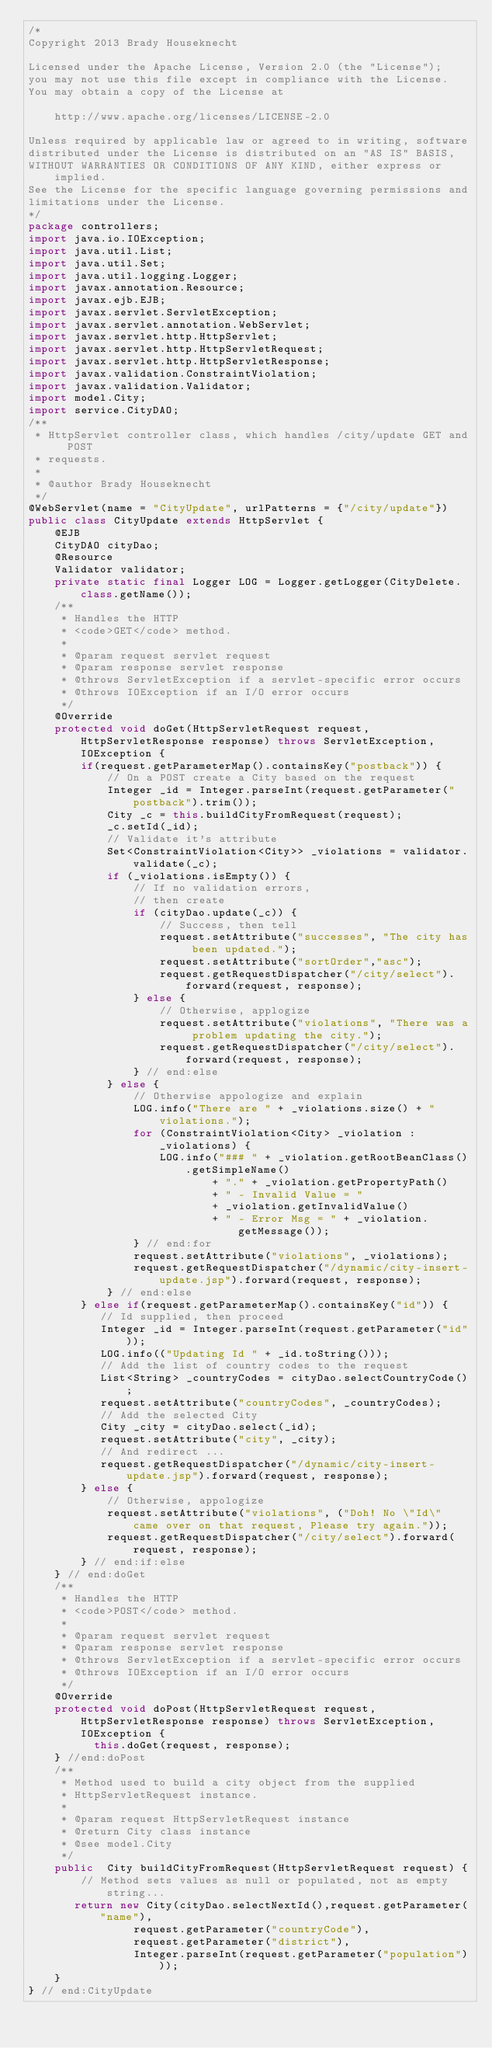Convert code to text. <code><loc_0><loc_0><loc_500><loc_500><_Java_>/*
Copyright 2013 Brady Houseknecht

Licensed under the Apache License, Version 2.0 (the "License");
you may not use this file except in compliance with the License.
You may obtain a copy of the License at

    http://www.apache.org/licenses/LICENSE-2.0

Unless required by applicable law or agreed to in writing, software
distributed under the License is distributed on an "AS IS" BASIS,
WITHOUT WARRANTIES OR CONDITIONS OF ANY KIND, either express or implied.
See the License for the specific language governing permissions and
limitations under the License.
*/
package controllers;
import java.io.IOException;
import java.util.List;
import java.util.Set;
import java.util.logging.Logger;
import javax.annotation.Resource;
import javax.ejb.EJB;
import javax.servlet.ServletException;
import javax.servlet.annotation.WebServlet;
import javax.servlet.http.HttpServlet;
import javax.servlet.http.HttpServletRequest;
import javax.servlet.http.HttpServletResponse;
import javax.validation.ConstraintViolation;
import javax.validation.Validator;
import model.City;
import service.CityDAO;
/**
 * HttpServlet controller class, which handles /city/update GET and POST
 * requests.
 * 
 * @author Brady Houseknecht
 */
@WebServlet(name = "CityUpdate", urlPatterns = {"/city/update"})
public class CityUpdate extends HttpServlet {
    @EJB
    CityDAO cityDao;
    @Resource
    Validator validator;
    private static final Logger LOG = Logger.getLogger(CityDelete.class.getName());
    /**
     * Handles the HTTP
     * <code>GET</code> method.
     *
     * @param request servlet request
     * @param response servlet response
     * @throws ServletException if a servlet-specific error occurs
     * @throws IOException if an I/O error occurs
     */
    @Override
    protected void doGet(HttpServletRequest request, HttpServletResponse response) throws ServletException, IOException {
        if(request.getParameterMap().containsKey("postback")) {
            // On a POST create a City based on the request
            Integer _id = Integer.parseInt(request.getParameter("postback").trim());
            City _c = this.buildCityFromRequest(request);
            _c.setId(_id);
            // Validate it's attribute
            Set<ConstraintViolation<City>> _violations = validator.validate(_c);
            if (_violations.isEmpty()) {
                // If no validation errors, 
                // then create
                if (cityDao.update(_c)) {
                    // Success, then tell
                    request.setAttribute("successes", "The city has been updated.");
                    request.setAttribute("sortOrder","asc");
                    request.getRequestDispatcher("/city/select").forward(request, response);
                } else {
                    // Otherwise, applogize
                    request.setAttribute("violations", "There was a problem updating the city.");
                    request.getRequestDispatcher("/city/select").forward(request, response);
                } // end:else
            } else {
                // Otherwise appologize and explain
                LOG.info("There are " + _violations.size() + " violations.");
                for (ConstraintViolation<City> _violation : _violations) {
                    LOG.info("### " + _violation.getRootBeanClass().getSimpleName()
                            + "." + _violation.getPropertyPath()
                            + " - Invalid Value = "
                            + _violation.getInvalidValue()
                            + " - Error Msg = " + _violation.getMessage());
                } // end:for            
                request.setAttribute("violations", _violations);
                request.getRequestDispatcher("/dynamic/city-insert-update.jsp").forward(request, response);
            } // end:else 
        } else if(request.getParameterMap().containsKey("id")) {
           // Id supplied, then proceed
           Integer _id = Integer.parseInt(request.getParameter("id"));
           LOG.info(("Updating Id " + _id.toString()));
           // Add the list of country codes to the request
           List<String> _countryCodes = cityDao.selectCountryCode();
           request.setAttribute("countryCodes", _countryCodes);
           // Add the selected City 
           City _city = cityDao.select(_id);
           request.setAttribute("city", _city);
           // And redirect ...
           request.getRequestDispatcher("/dynamic/city-insert-update.jsp").forward(request, response);
        } else {
            // Otherwise, appologize
            request.setAttribute("violations", ("Doh! No \"Id\" came over on that request, Please try again."));
            request.getRequestDispatcher("/city/select").forward(request, response);
        } // end:if:else
    } // end:doGet
    /**
     * Handles the HTTP
     * <code>POST</code> method.
     *
     * @param request servlet request
     * @param response servlet response
     * @throws ServletException if a servlet-specific error occurs
     * @throws IOException if an I/O error occurs
     */
    @Override
    protected void doPost(HttpServletRequest request, HttpServletResponse response) throws ServletException, IOException {
          this.doGet(request, response);
    } //end:doPost
    /**
     * Method used to build a city object from the supplied
     * HttpServletRequest instance.
     * 
     * @param request HttpServletRequest instance 
     * @return City class instance
     * @see model.City
     */
    public  City buildCityFromRequest(HttpServletRequest request) {
        // Method sets values as null or populated, not as empty string...
       return new City(cityDao.selectNextId(),request.getParameter("name"),
                request.getParameter("countryCode"),
                request.getParameter("district"),
                Integer.parseInt(request.getParameter("population")));
    }
} // end:CityUpdate
</code> 